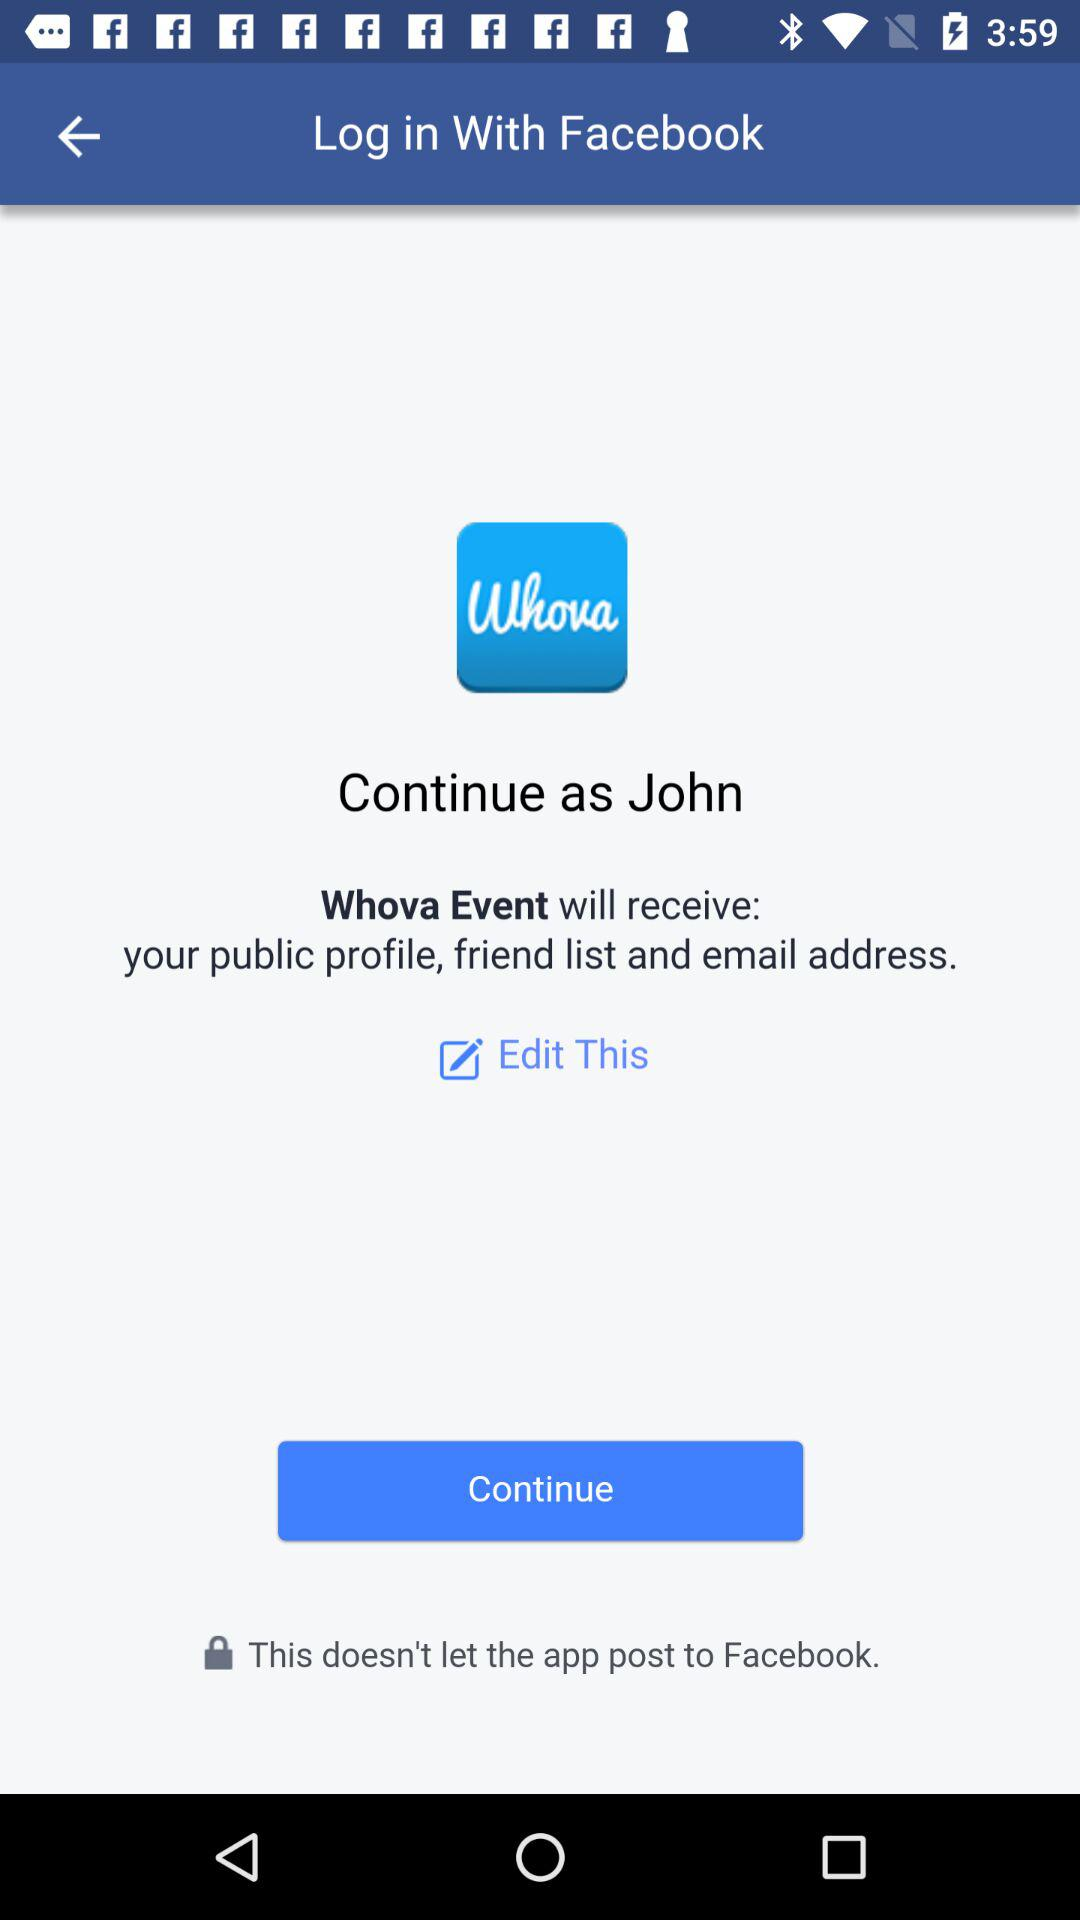What is the login name? The login name is John. 